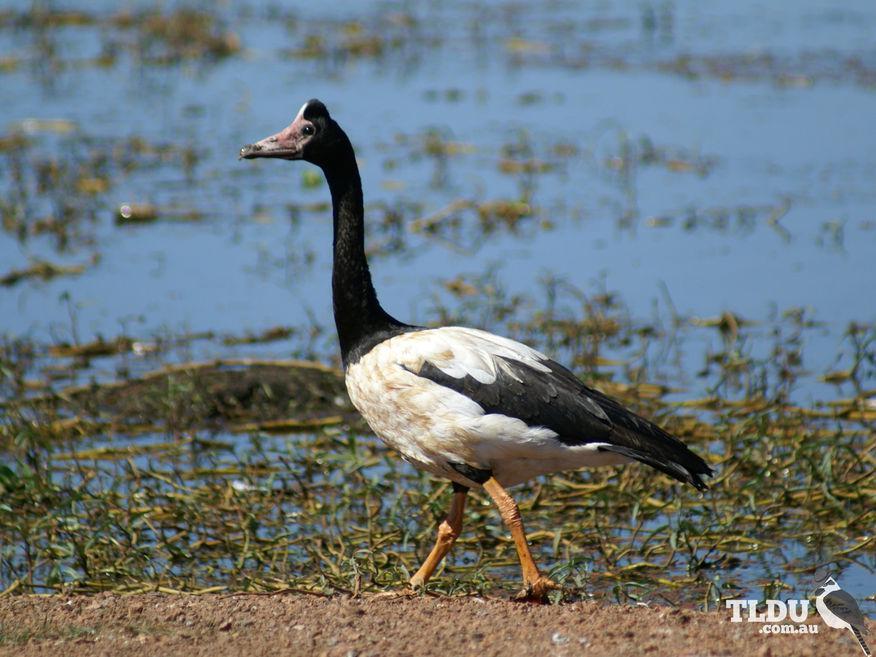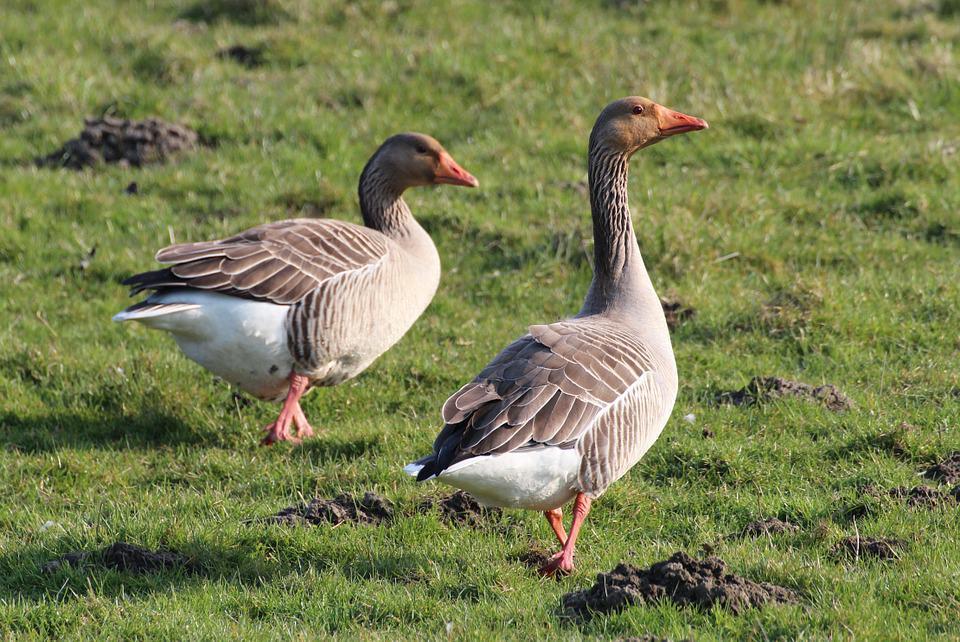The first image is the image on the left, the second image is the image on the right. Assess this claim about the two images: "The right image shows ducks with multiple ducklings.". Correct or not? Answer yes or no. No. 